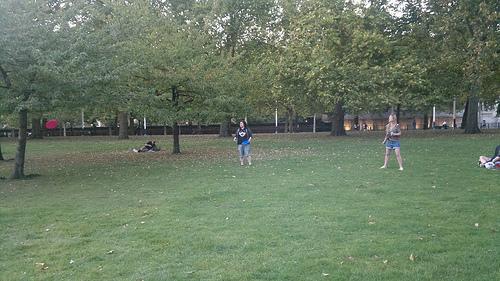How many people are standing?
Give a very brief answer. 2. 